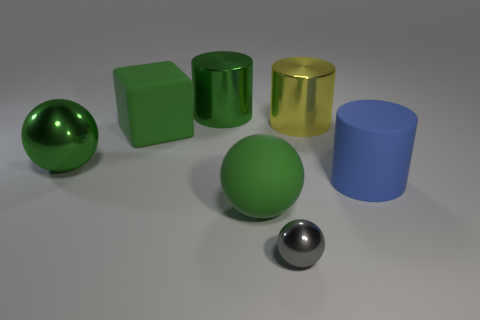Is the object behind the big yellow shiny object made of the same material as the blue cylinder? While both the object behind the big yellow shiny object and the blue cylinder appear to be smooth and possibly reflective, there are subtle differences in their texture and sheen that suggest they might not be made of exactly the same material. 